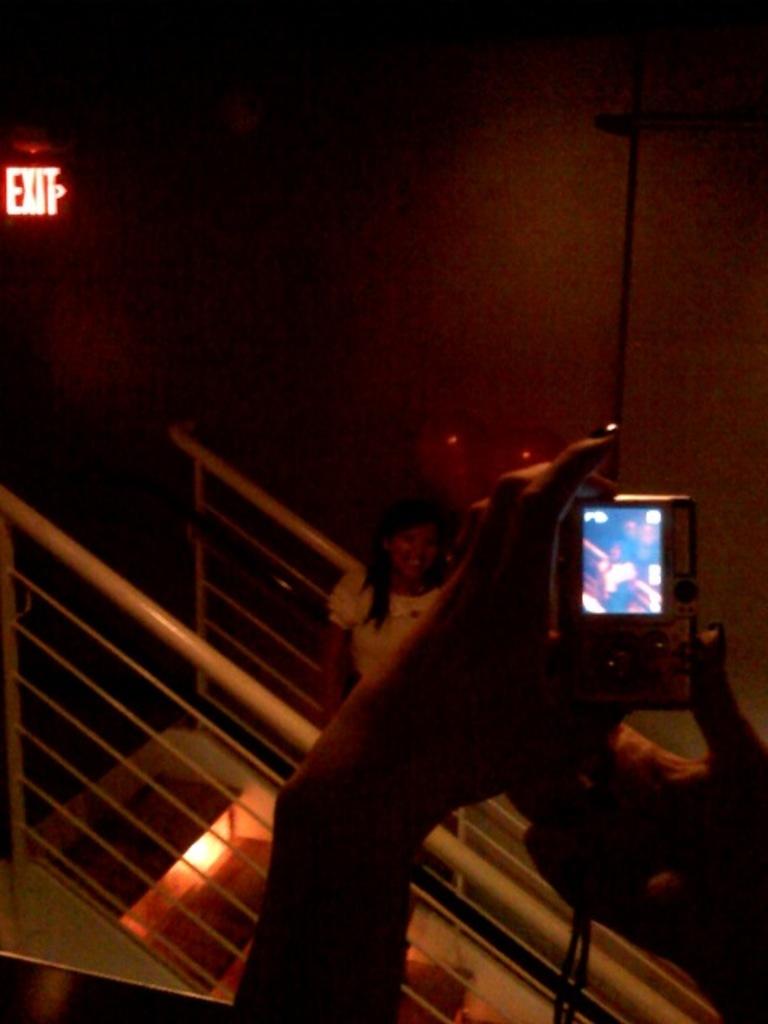What sign is up top?
Your response must be concise. Exit. 